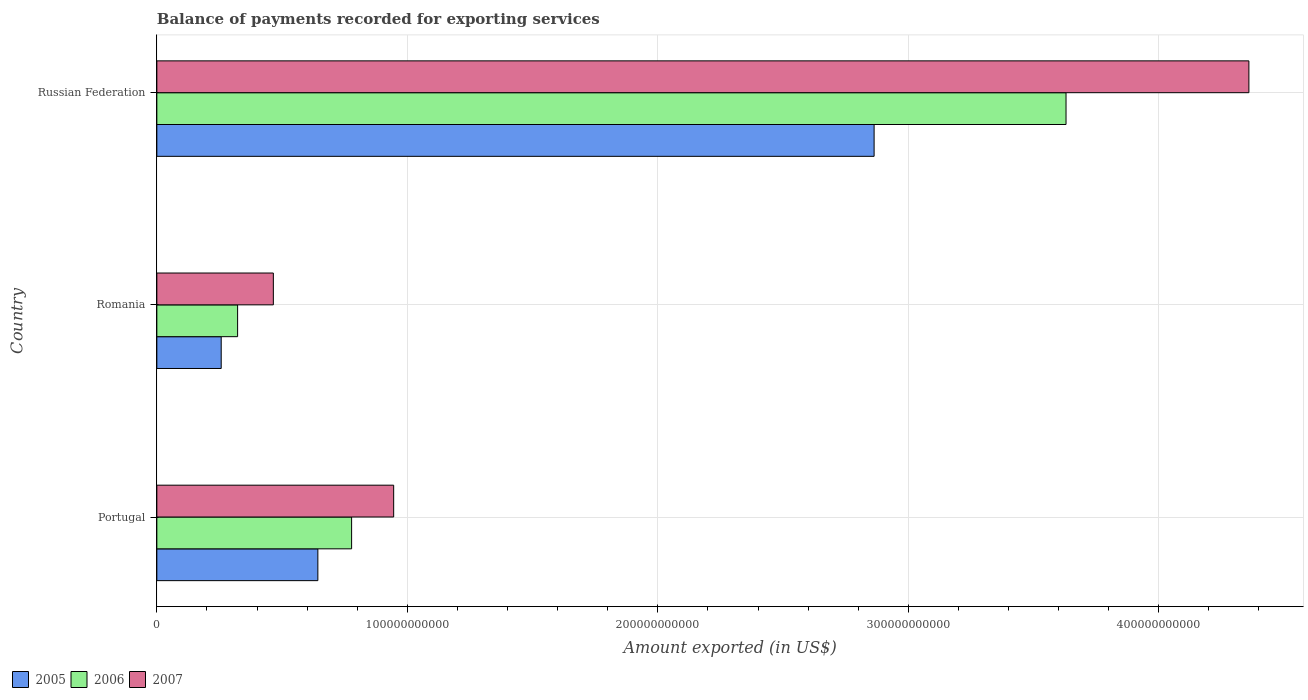How many different coloured bars are there?
Your answer should be very brief. 3. Are the number of bars per tick equal to the number of legend labels?
Make the answer very short. Yes. How many bars are there on the 3rd tick from the top?
Give a very brief answer. 3. What is the label of the 3rd group of bars from the top?
Give a very brief answer. Portugal. What is the amount exported in 2005 in Russian Federation?
Your response must be concise. 2.86e+11. Across all countries, what is the maximum amount exported in 2006?
Provide a short and direct response. 3.63e+11. Across all countries, what is the minimum amount exported in 2005?
Offer a very short reply. 2.57e+1. In which country was the amount exported in 2006 maximum?
Give a very brief answer. Russian Federation. In which country was the amount exported in 2007 minimum?
Ensure brevity in your answer.  Romania. What is the total amount exported in 2006 in the graph?
Ensure brevity in your answer.  4.73e+11. What is the difference between the amount exported in 2006 in Portugal and that in Romania?
Provide a succinct answer. 4.55e+1. What is the difference between the amount exported in 2005 in Romania and the amount exported in 2006 in Portugal?
Make the answer very short. -5.21e+1. What is the average amount exported in 2007 per country?
Ensure brevity in your answer.  1.92e+11. What is the difference between the amount exported in 2007 and amount exported in 2006 in Russian Federation?
Give a very brief answer. 7.30e+1. What is the ratio of the amount exported in 2005 in Portugal to that in Russian Federation?
Keep it short and to the point. 0.22. Is the difference between the amount exported in 2007 in Portugal and Russian Federation greater than the difference between the amount exported in 2006 in Portugal and Russian Federation?
Provide a succinct answer. No. What is the difference between the highest and the second highest amount exported in 2007?
Keep it short and to the point. 3.41e+11. What is the difference between the highest and the lowest amount exported in 2005?
Keep it short and to the point. 2.61e+11. Is the sum of the amount exported in 2007 in Portugal and Russian Federation greater than the maximum amount exported in 2005 across all countries?
Your answer should be compact. Yes. Is it the case that in every country, the sum of the amount exported in 2007 and amount exported in 2005 is greater than the amount exported in 2006?
Offer a very short reply. Yes. How many bars are there?
Make the answer very short. 9. Are all the bars in the graph horizontal?
Provide a short and direct response. Yes. What is the difference between two consecutive major ticks on the X-axis?
Your answer should be compact. 1.00e+11. Are the values on the major ticks of X-axis written in scientific E-notation?
Make the answer very short. No. Does the graph contain grids?
Provide a succinct answer. Yes. What is the title of the graph?
Provide a succinct answer. Balance of payments recorded for exporting services. What is the label or title of the X-axis?
Make the answer very short. Amount exported (in US$). What is the Amount exported (in US$) of 2005 in Portugal?
Your response must be concise. 6.43e+1. What is the Amount exported (in US$) in 2006 in Portugal?
Offer a very short reply. 7.78e+1. What is the Amount exported (in US$) in 2007 in Portugal?
Your answer should be compact. 9.45e+1. What is the Amount exported (in US$) in 2005 in Romania?
Your answer should be compact. 2.57e+1. What is the Amount exported (in US$) in 2006 in Romania?
Your answer should be compact. 3.22e+1. What is the Amount exported (in US$) in 2007 in Romania?
Provide a short and direct response. 4.65e+1. What is the Amount exported (in US$) of 2005 in Russian Federation?
Make the answer very short. 2.86e+11. What is the Amount exported (in US$) in 2006 in Russian Federation?
Make the answer very short. 3.63e+11. What is the Amount exported (in US$) in 2007 in Russian Federation?
Your response must be concise. 4.36e+11. Across all countries, what is the maximum Amount exported (in US$) of 2005?
Your answer should be very brief. 2.86e+11. Across all countries, what is the maximum Amount exported (in US$) in 2006?
Your answer should be compact. 3.63e+11. Across all countries, what is the maximum Amount exported (in US$) of 2007?
Keep it short and to the point. 4.36e+11. Across all countries, what is the minimum Amount exported (in US$) in 2005?
Ensure brevity in your answer.  2.57e+1. Across all countries, what is the minimum Amount exported (in US$) of 2006?
Your answer should be very brief. 3.22e+1. Across all countries, what is the minimum Amount exported (in US$) in 2007?
Your answer should be very brief. 4.65e+1. What is the total Amount exported (in US$) in 2005 in the graph?
Provide a short and direct response. 3.76e+11. What is the total Amount exported (in US$) of 2006 in the graph?
Your answer should be compact. 4.73e+11. What is the total Amount exported (in US$) of 2007 in the graph?
Provide a short and direct response. 5.77e+11. What is the difference between the Amount exported (in US$) of 2005 in Portugal and that in Romania?
Offer a very short reply. 3.86e+1. What is the difference between the Amount exported (in US$) of 2006 in Portugal and that in Romania?
Make the answer very short. 4.55e+1. What is the difference between the Amount exported (in US$) in 2007 in Portugal and that in Romania?
Provide a short and direct response. 4.80e+1. What is the difference between the Amount exported (in US$) in 2005 in Portugal and that in Russian Federation?
Your response must be concise. -2.22e+11. What is the difference between the Amount exported (in US$) of 2006 in Portugal and that in Russian Federation?
Provide a succinct answer. -2.85e+11. What is the difference between the Amount exported (in US$) in 2007 in Portugal and that in Russian Federation?
Ensure brevity in your answer.  -3.41e+11. What is the difference between the Amount exported (in US$) of 2005 in Romania and that in Russian Federation?
Your response must be concise. -2.61e+11. What is the difference between the Amount exported (in US$) in 2006 in Romania and that in Russian Federation?
Your answer should be compact. -3.31e+11. What is the difference between the Amount exported (in US$) of 2007 in Romania and that in Russian Federation?
Give a very brief answer. -3.89e+11. What is the difference between the Amount exported (in US$) in 2005 in Portugal and the Amount exported (in US$) in 2006 in Romania?
Provide a succinct answer. 3.20e+1. What is the difference between the Amount exported (in US$) in 2005 in Portugal and the Amount exported (in US$) in 2007 in Romania?
Your answer should be very brief. 1.78e+1. What is the difference between the Amount exported (in US$) of 2006 in Portugal and the Amount exported (in US$) of 2007 in Romania?
Provide a succinct answer. 3.12e+1. What is the difference between the Amount exported (in US$) in 2005 in Portugal and the Amount exported (in US$) in 2006 in Russian Federation?
Provide a short and direct response. -2.99e+11. What is the difference between the Amount exported (in US$) of 2005 in Portugal and the Amount exported (in US$) of 2007 in Russian Federation?
Ensure brevity in your answer.  -3.72e+11. What is the difference between the Amount exported (in US$) in 2006 in Portugal and the Amount exported (in US$) in 2007 in Russian Federation?
Your answer should be compact. -3.58e+11. What is the difference between the Amount exported (in US$) in 2005 in Romania and the Amount exported (in US$) in 2006 in Russian Federation?
Provide a succinct answer. -3.37e+11. What is the difference between the Amount exported (in US$) in 2005 in Romania and the Amount exported (in US$) in 2007 in Russian Federation?
Ensure brevity in your answer.  -4.10e+11. What is the difference between the Amount exported (in US$) in 2006 in Romania and the Amount exported (in US$) in 2007 in Russian Federation?
Your answer should be very brief. -4.04e+11. What is the average Amount exported (in US$) in 2005 per country?
Make the answer very short. 1.25e+11. What is the average Amount exported (in US$) of 2006 per country?
Offer a terse response. 1.58e+11. What is the average Amount exported (in US$) of 2007 per country?
Provide a short and direct response. 1.92e+11. What is the difference between the Amount exported (in US$) in 2005 and Amount exported (in US$) in 2006 in Portugal?
Ensure brevity in your answer.  -1.35e+1. What is the difference between the Amount exported (in US$) of 2005 and Amount exported (in US$) of 2007 in Portugal?
Ensure brevity in your answer.  -3.03e+1. What is the difference between the Amount exported (in US$) in 2006 and Amount exported (in US$) in 2007 in Portugal?
Your answer should be very brief. -1.68e+1. What is the difference between the Amount exported (in US$) in 2005 and Amount exported (in US$) in 2006 in Romania?
Keep it short and to the point. -6.55e+09. What is the difference between the Amount exported (in US$) of 2005 and Amount exported (in US$) of 2007 in Romania?
Your answer should be very brief. -2.08e+1. What is the difference between the Amount exported (in US$) in 2006 and Amount exported (in US$) in 2007 in Romania?
Ensure brevity in your answer.  -1.43e+1. What is the difference between the Amount exported (in US$) of 2005 and Amount exported (in US$) of 2006 in Russian Federation?
Provide a short and direct response. -7.66e+1. What is the difference between the Amount exported (in US$) of 2005 and Amount exported (in US$) of 2007 in Russian Federation?
Your response must be concise. -1.50e+11. What is the difference between the Amount exported (in US$) in 2006 and Amount exported (in US$) in 2007 in Russian Federation?
Offer a terse response. -7.30e+1. What is the ratio of the Amount exported (in US$) of 2005 in Portugal to that in Romania?
Give a very brief answer. 2.5. What is the ratio of the Amount exported (in US$) in 2006 in Portugal to that in Romania?
Offer a terse response. 2.41. What is the ratio of the Amount exported (in US$) in 2007 in Portugal to that in Romania?
Offer a very short reply. 2.03. What is the ratio of the Amount exported (in US$) in 2005 in Portugal to that in Russian Federation?
Keep it short and to the point. 0.22. What is the ratio of the Amount exported (in US$) in 2006 in Portugal to that in Russian Federation?
Your response must be concise. 0.21. What is the ratio of the Amount exported (in US$) of 2007 in Portugal to that in Russian Federation?
Provide a succinct answer. 0.22. What is the ratio of the Amount exported (in US$) in 2005 in Romania to that in Russian Federation?
Ensure brevity in your answer.  0.09. What is the ratio of the Amount exported (in US$) in 2006 in Romania to that in Russian Federation?
Give a very brief answer. 0.09. What is the ratio of the Amount exported (in US$) of 2007 in Romania to that in Russian Federation?
Provide a succinct answer. 0.11. What is the difference between the highest and the second highest Amount exported (in US$) of 2005?
Your response must be concise. 2.22e+11. What is the difference between the highest and the second highest Amount exported (in US$) of 2006?
Your response must be concise. 2.85e+11. What is the difference between the highest and the second highest Amount exported (in US$) in 2007?
Your answer should be compact. 3.41e+11. What is the difference between the highest and the lowest Amount exported (in US$) of 2005?
Offer a very short reply. 2.61e+11. What is the difference between the highest and the lowest Amount exported (in US$) in 2006?
Your answer should be very brief. 3.31e+11. What is the difference between the highest and the lowest Amount exported (in US$) of 2007?
Keep it short and to the point. 3.89e+11. 